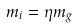Convert formula to latex. <formula><loc_0><loc_0><loc_500><loc_500>m _ { i } = \eta m _ { \sl g }</formula> 